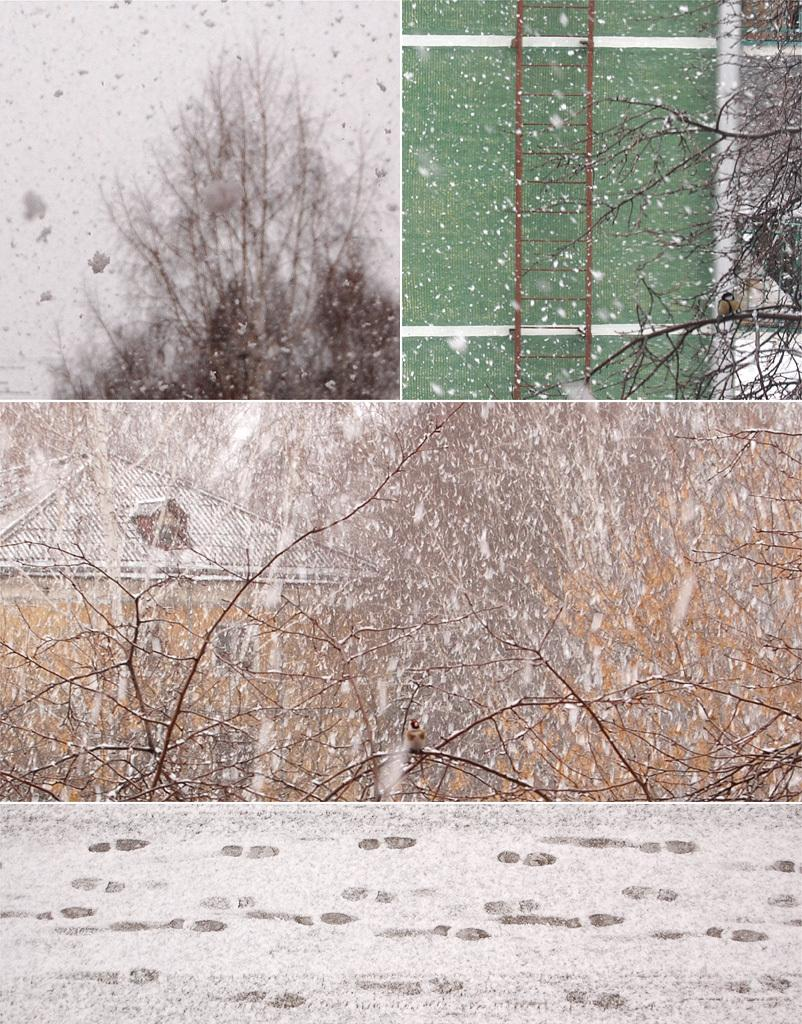How many images are included in the collage? The collage contains three different images. What is the common theme among the images in the collage? Each image depicts snowfall during the monsoon season. What is a common feature in each of the images? Each image features a dry tree. How many toads can be seen in the collage? There are no toads present in the collage; the images depict snowfall and dry trees during the monsoon season. 